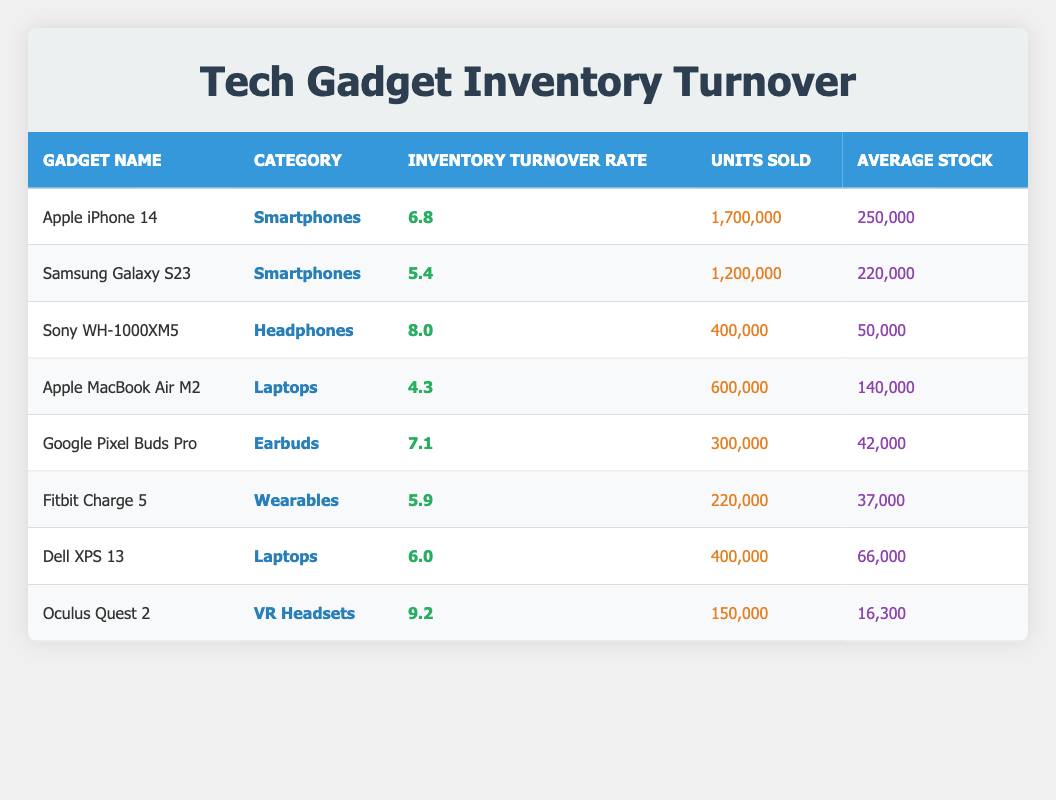What is the inventory turnover rate of the Apple iPhone 14? The inventory turnover rate is explicitly listed in the table under the "Inventory Turnover Rate" column for the Apple iPhone 14, which shows a value of 6.8.
Answer: 6.8 Which gadget has the highest inventory turnover rate? By examining the "Inventory Turnover Rate" column for each gadget, the Oculus Quest 2 has the highest value of 9.2 among the listed gadgets.
Answer: Oculus Quest 2 Is the average stock for the Sony WH-1000XM5 higher than the average stock for the Google Pixel Buds Pro? The average stock for Sony WH-1000XM5 is 50,000 and for Google Pixel Buds Pro is 42,000. Since 50,000 is greater than 42,000, the statement is true.
Answer: Yes What is the total number of units sold for all laptops combined? The units sold for laptops are 600,000 for Apple MacBook Air M2 and 400,000 for Dell XPS 13. Adding these gives 600,000 + 400,000 = 1,000,000 units sold for all laptops.
Answer: 1,000,000 What is the average inventory turnover rate for all smartphones? The inventory turnover rates for smartphones are 6.8 for Apple iPhone 14 and 5.4 for Samsung Galaxy S23. The average is calculated by (6.8 + 5.4) / 2 = 6.1.
Answer: 6.1 Are there any gadgets in the table with an inventory turnover rate below 5.0? By checking the "Inventory Turnover Rate" column, the lowest rate is 4.3 for the Apple MacBook Air M2, which is below 5.0. Therefore, there is at least one gadget that meets this criterion.
Answer: Yes How many units were sold for the Sony WH-1000XM5 and is it less than 500,000? The table states that the Sony WH-1000XM5 sold 400,000 units. Since 400,000 is indeed less than 500,000, this statement is correct.
Answer: Yes If the average stock for the Oculus Quest 2 is 16,300, how many times greater is the inventory turnover rate of the Oculus Quest 2 (9.2) than its average stock? The inventory turnover rate for the Oculus Quest 2 is 9.2 and the average stock is 16,300. We calculate how many times greater it is by dividing: 9.2 / (16,300 / 1) which gives approximately 0.000564, thus it is not directly comparable.
Answer: Not applicable What category does the Google Pixel Buds Pro belong to? The Google Pixel Buds Pro's category is explicitly stated in the "Category" column of the table, where it is categorized as "Earbuds."
Answer: Earbuds 